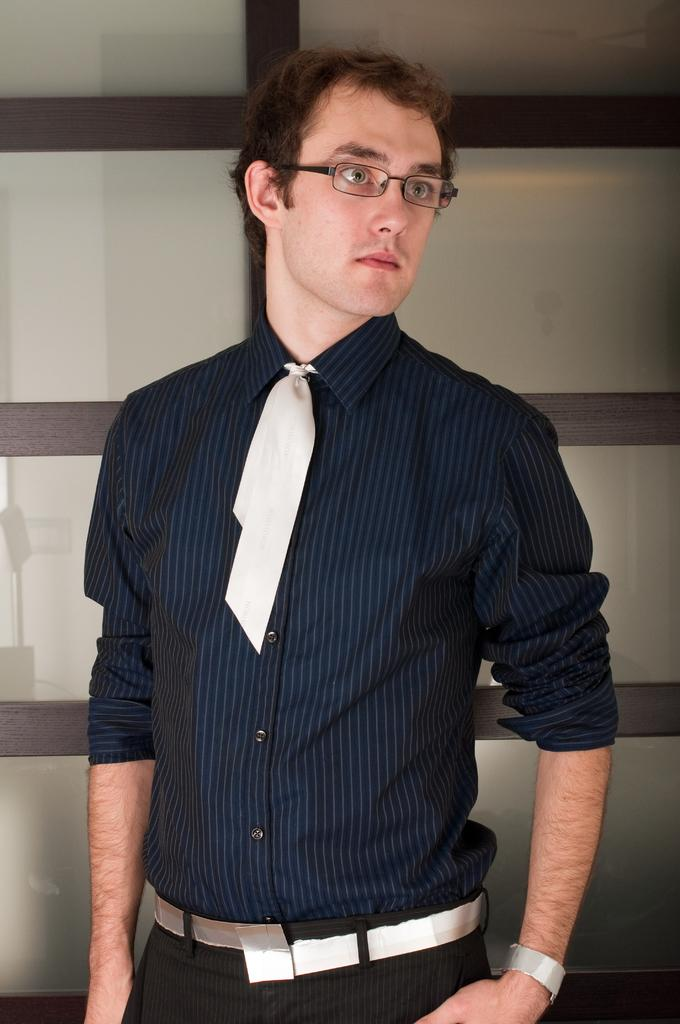What is the main subject of the image? There is a person in the image. What color is the shirt the person is wearing? The person is wearing a blue shirt. What color are the pants the person is wearing? The person is wearing black pants. What type of accessory is the person wearing around their neck? The person is wearing a tie. What type of eyewear is the person wearing? The person is wearing spectacles. What can be seen in the background of the image? There is a glass door in the background of the image. What type of scent can be detected coming from the person in the image? There is no information about the person's scent in the image, so it cannot be determined. 